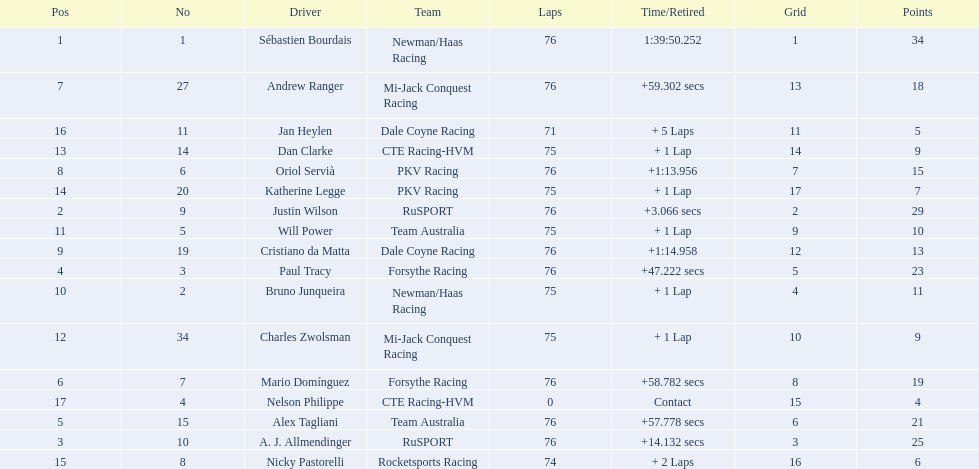What was alex taglini's final score in the tecate grand prix? 21. What was paul tracy's final score in the tecate grand prix? 23. Which driver finished first? Paul Tracy. 